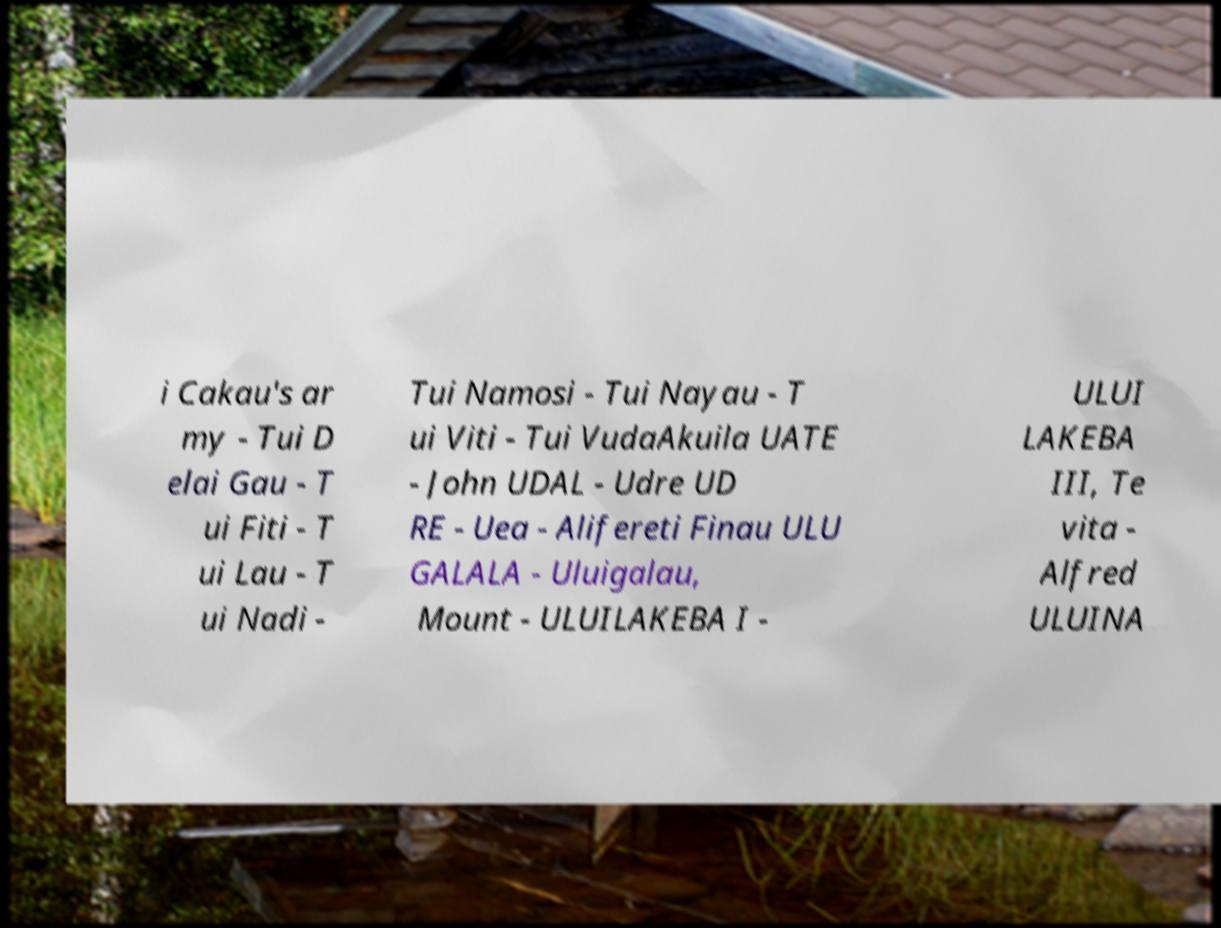Please read and relay the text visible in this image. What does it say? i Cakau's ar my - Tui D elai Gau - T ui Fiti - T ui Lau - T ui Nadi - Tui Namosi - Tui Nayau - T ui Viti - Tui VudaAkuila UATE - John UDAL - Udre UD RE - Uea - Alifereti Finau ULU GALALA - Uluigalau, Mount - ULUILAKEBA I - ULUI LAKEBA III, Te vita - Alfred ULUINA 